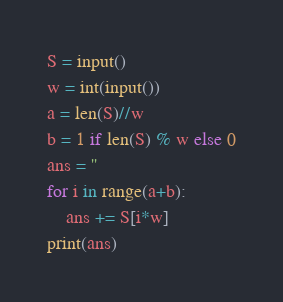Convert code to text. <code><loc_0><loc_0><loc_500><loc_500><_Python_>S = input()
w = int(input())
a = len(S)//w
b = 1 if len(S) % w else 0
ans = ''
for i in range(a+b):
    ans += S[i*w]
print(ans)</code> 